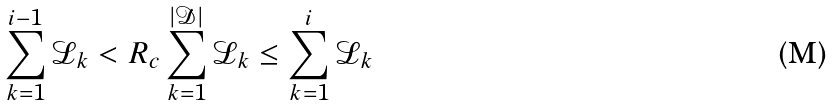<formula> <loc_0><loc_0><loc_500><loc_500>\sum _ { k = 1 } ^ { i - 1 } \mathcal { L } _ { k } < R _ { c } \sum _ { k = 1 } ^ { | \mathcal { D } | } \mathcal { L } _ { k } \leq \sum _ { k = 1 } ^ { i } \mathcal { L } _ { k }</formula> 